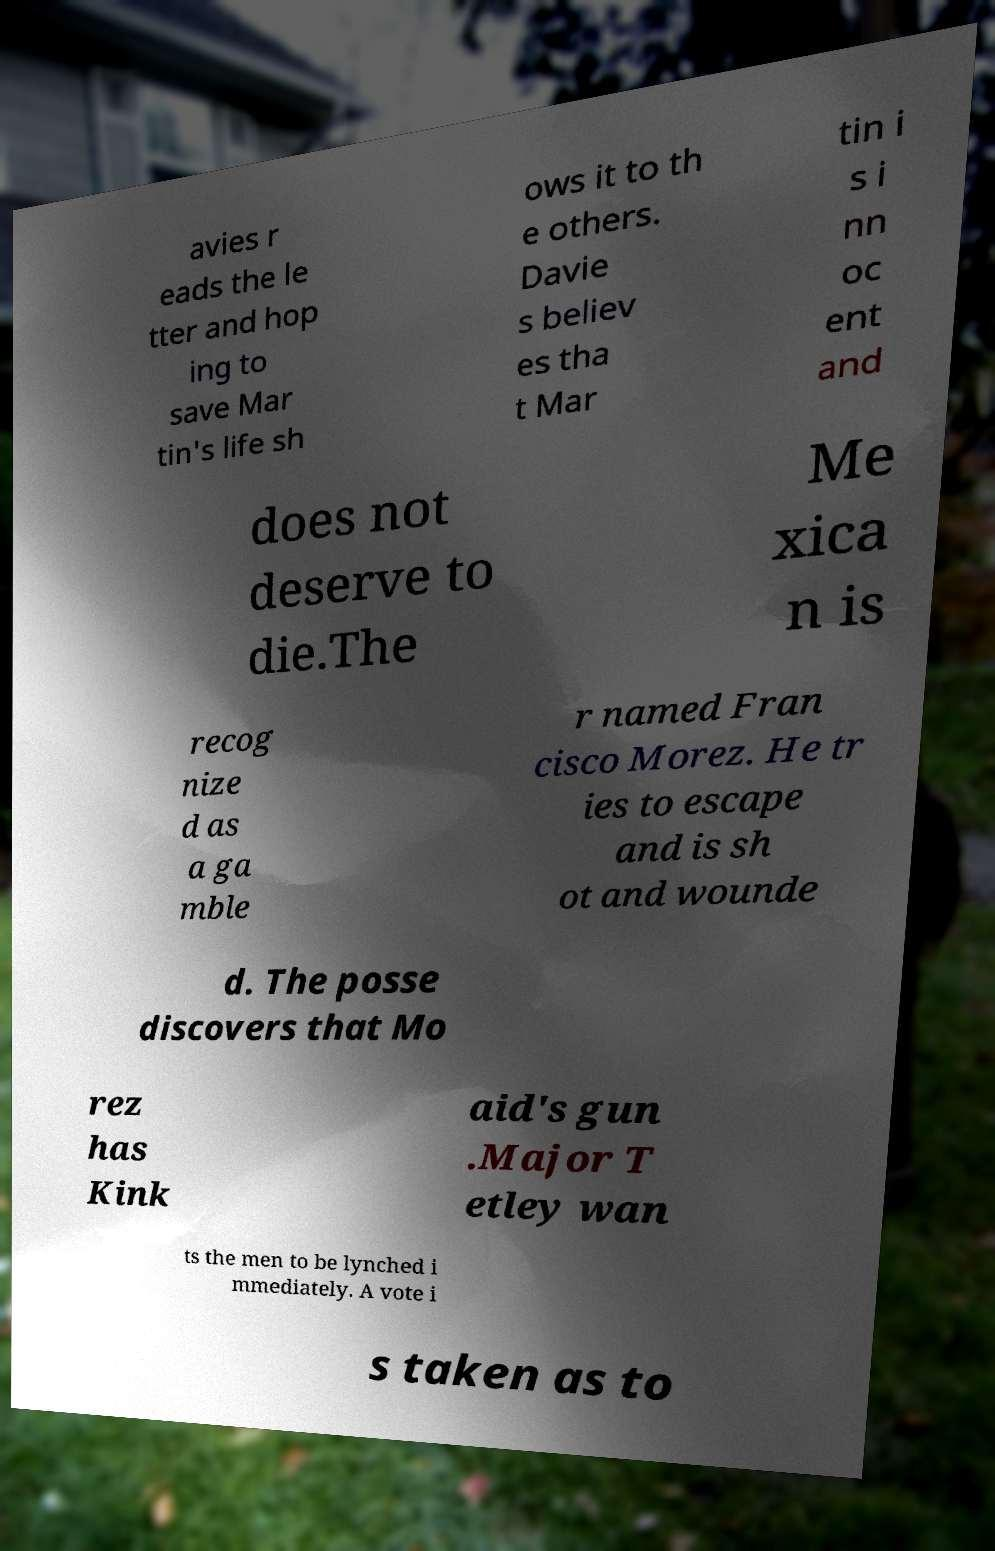I need the written content from this picture converted into text. Can you do that? avies r eads the le tter and hop ing to save Mar tin's life sh ows it to th e others. Davie s believ es tha t Mar tin i s i nn oc ent and does not deserve to die.The Me xica n is recog nize d as a ga mble r named Fran cisco Morez. He tr ies to escape and is sh ot and wounde d. The posse discovers that Mo rez has Kink aid's gun .Major T etley wan ts the men to be lynched i mmediately. A vote i s taken as to 